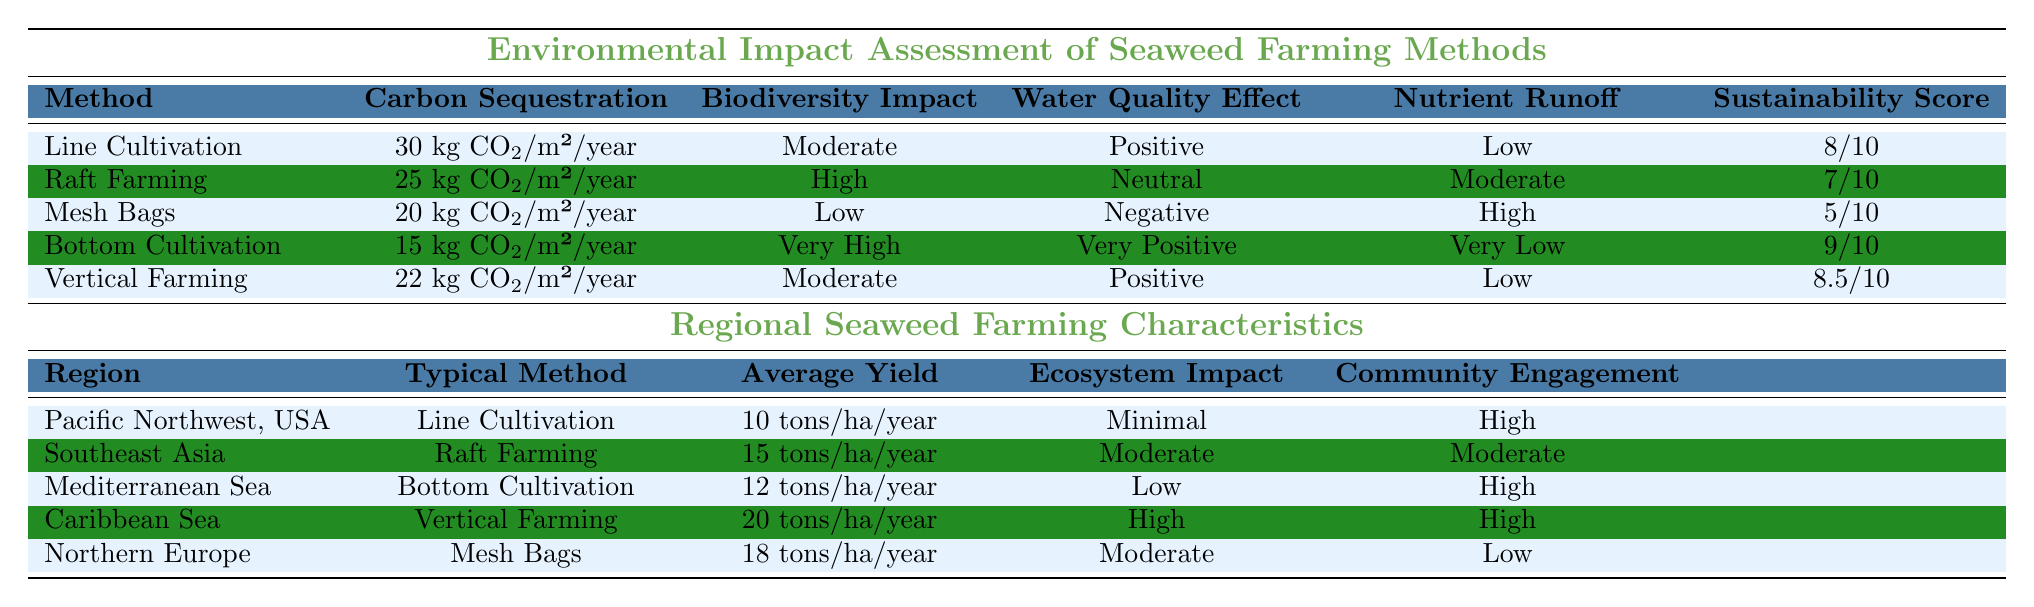What is the carbon sequestration value of Line Cultivation? Referring to the table, the carbon sequestration value for Line Cultivation is listed as 30 kg CO2/m²/year.
Answer: 30 kg CO2/m²/year Which farming method has the highest Sustainability Score? The table shows that Bottom Cultivation has a Sustainability Score of 9/10, which is the highest among all methods.
Answer: Bottom Cultivation Does Raft Farming have a positive effect on water quality? According to the table, Raft Farming has a Neutral water quality effect, which means it does not positively impact water quality.
Answer: No Which farming method results in the highest nutrient runoff? The table indicates that Mesh Bags have a High nutrient runoff, which is higher than other methods listed.
Answer: Mesh Bags What is the average yield of seaweed farming in the Caribbean Sea? The table states that the average yield for the Caribbean Sea, employing Vertical Farming, is 20 tons/ha/year.
Answer: 20 tons/ha/year How does the biodiversity impact of Bottom Cultivation compare to Mesh Bags? The biodiversity impact for Bottom Cultivation is Very High, while for Mesh Bags it is Low, indicating a significant difference in biodiversity impact.
Answer: Bottom Cultivation has a Very High impact; Mesh Bags have a Low impact Which method has the lowest carbon sequestration value and its corresponding score? According to the table, Bottom Cultivation has the lowest carbon sequestration value of 15 kg CO2/m²/year, with a Sustainability Score of 9/10.
Answer: 15 kg CO2/m²/year and Sustainability Score of 9/10 What is the combined carbon sequestration for Raft Farming and Vertical Farming? The carbon sequestration values for Raft Farming and Vertical Farming are 25 kg CO2/m²/year and 22 kg CO2/m²/year respectively, so the sum is 25 + 22 = 47 kg CO2/m²/year.
Answer: 47 kg CO2/m²/year Does the Pacific Northwest use the same typical farming method as Northern Europe? The table shows that the Pacific Northwest uses Line Cultivation while Northern Europe uses Mesh Bags, so they do not use the same method.
Answer: No What is the average nutrient runoff for the listed farming methods? The nutrient runoff values are Low, Moderate, High, Very Low, and Low for the five methods. To find the average, we could assign numerical values (Low=1, Moderate=2, High=3, Very Low=0), yielding (1+2+3+0+1)/5 = 1.4, which averages out to a Moderate level.
Answer: Moderate Which region has a high level of community engagement? The Mediterranean Sea, Caribbean Sea and Pacific Northwest all have a high level of community engagement, per the table.
Answer: Mediterranean Sea, Caribbean Sea, Pacific Northwest 